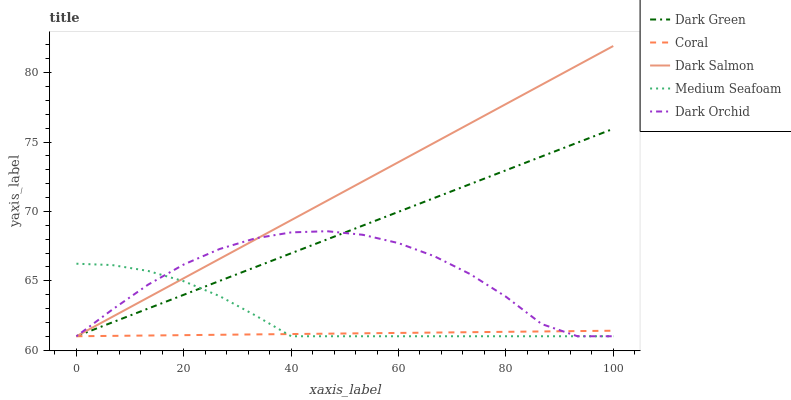Does Coral have the minimum area under the curve?
Answer yes or no. Yes. Does Dark Salmon have the maximum area under the curve?
Answer yes or no. Yes. Does Medium Seafoam have the minimum area under the curve?
Answer yes or no. No. Does Medium Seafoam have the maximum area under the curve?
Answer yes or no. No. Is Coral the smoothest?
Answer yes or no. Yes. Is Dark Orchid the roughest?
Answer yes or no. Yes. Is Medium Seafoam the smoothest?
Answer yes or no. No. Is Medium Seafoam the roughest?
Answer yes or no. No. Does Medium Seafoam have the highest value?
Answer yes or no. No. 